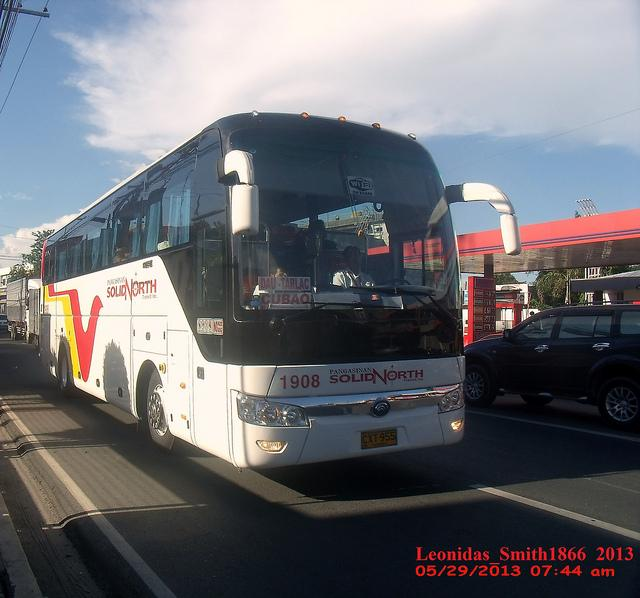What is the red building to the right of the bus used for? Please explain your reasoning. gas station. To the right in red is pumps where people drive up to. they then will pump liquid to drive around in. 